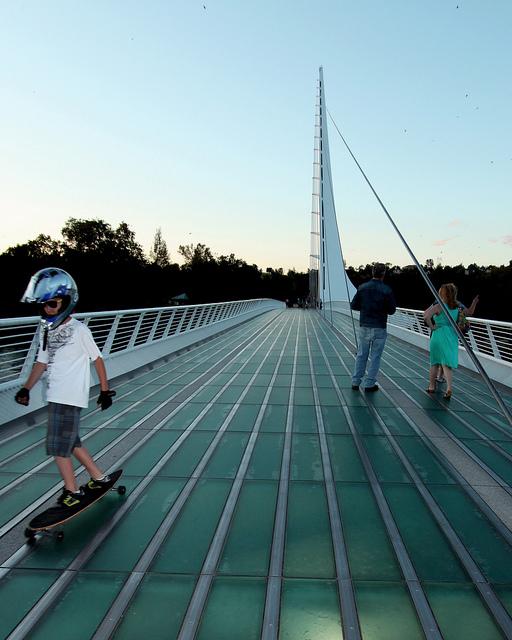What types of tracks are these?
Answer briefly. Skateboard. What is the boy doing?
Be succinct. Skateboarding. Is there more than one person skating?
Short answer required. No. Is the child wearing a helmet?
Answer briefly. Yes. Is there a train visible?
Write a very short answer. No. 